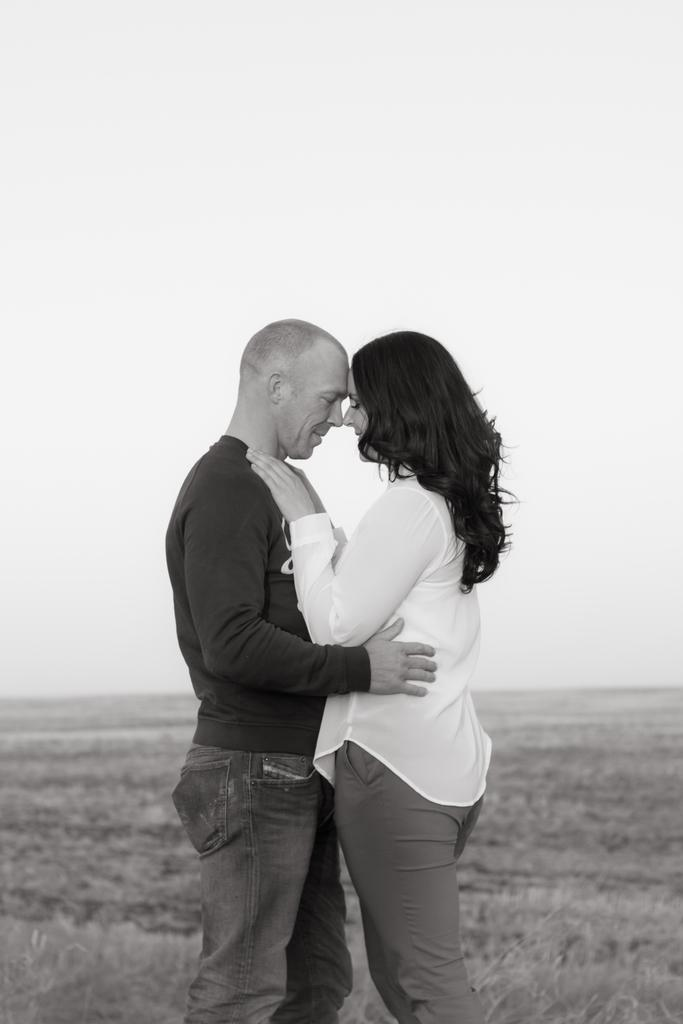What is the color scheme of the image? The image is in black and white. What is the person standing on in the image? The person is standing on grassland. Who is standing in front of the person in the image? There is a woman standing in front of the person. What is visible at the top of the image? The sky is visible at the top of the image. What type of poison is the person holding in the image? There is no poison present in the image; it features a person standing on grassland with a woman in front of them. 